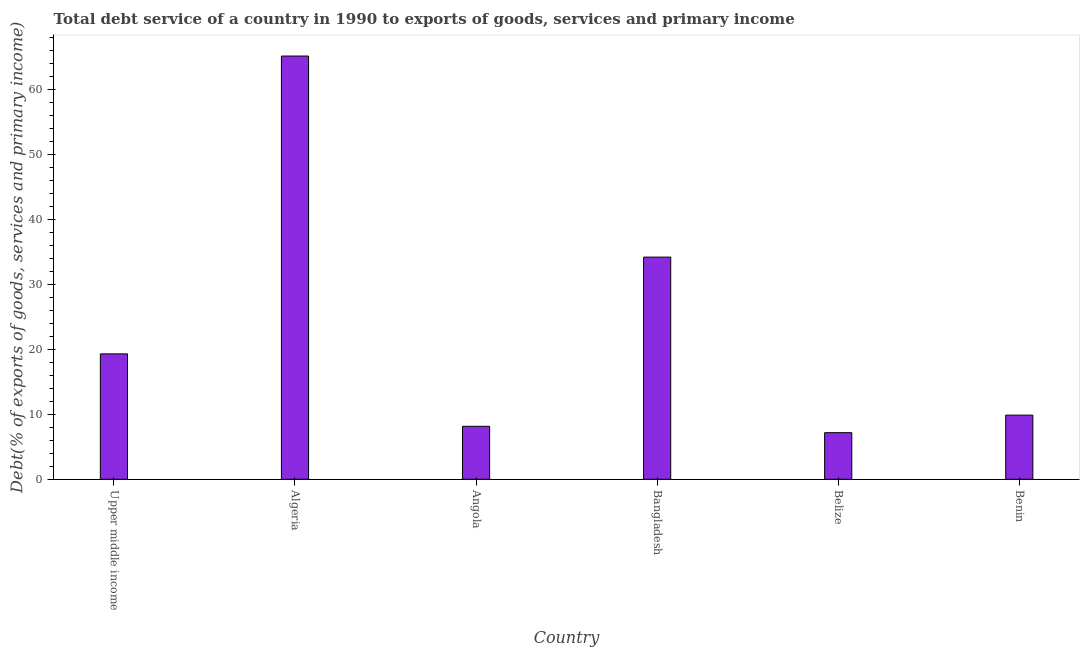What is the title of the graph?
Give a very brief answer. Total debt service of a country in 1990 to exports of goods, services and primary income. What is the label or title of the Y-axis?
Your response must be concise. Debt(% of exports of goods, services and primary income). What is the total debt service in Benin?
Ensure brevity in your answer.  9.86. Across all countries, what is the maximum total debt service?
Keep it short and to the point. 65.08. Across all countries, what is the minimum total debt service?
Ensure brevity in your answer.  7.17. In which country was the total debt service maximum?
Provide a succinct answer. Algeria. In which country was the total debt service minimum?
Make the answer very short. Belize. What is the sum of the total debt service?
Offer a terse response. 143.69. What is the difference between the total debt service in Algeria and Bangladesh?
Give a very brief answer. 30.92. What is the average total debt service per country?
Your response must be concise. 23.95. What is the median total debt service?
Your response must be concise. 14.57. What is the ratio of the total debt service in Angola to that in Bangladesh?
Keep it short and to the point. 0.24. Is the difference between the total debt service in Algeria and Belize greater than the difference between any two countries?
Your answer should be compact. Yes. What is the difference between the highest and the second highest total debt service?
Keep it short and to the point. 30.92. What is the difference between the highest and the lowest total debt service?
Provide a short and direct response. 57.91. How many bars are there?
Your response must be concise. 6. How many countries are there in the graph?
Your response must be concise. 6. What is the Debt(% of exports of goods, services and primary income) in Upper middle income?
Your response must be concise. 19.28. What is the Debt(% of exports of goods, services and primary income) in Algeria?
Provide a succinct answer. 65.08. What is the Debt(% of exports of goods, services and primary income) of Angola?
Offer a terse response. 8.14. What is the Debt(% of exports of goods, services and primary income) of Bangladesh?
Make the answer very short. 34.16. What is the Debt(% of exports of goods, services and primary income) in Belize?
Give a very brief answer. 7.17. What is the Debt(% of exports of goods, services and primary income) of Benin?
Make the answer very short. 9.86. What is the difference between the Debt(% of exports of goods, services and primary income) in Upper middle income and Algeria?
Provide a short and direct response. -45.8. What is the difference between the Debt(% of exports of goods, services and primary income) in Upper middle income and Angola?
Your response must be concise. 11.14. What is the difference between the Debt(% of exports of goods, services and primary income) in Upper middle income and Bangladesh?
Ensure brevity in your answer.  -14.88. What is the difference between the Debt(% of exports of goods, services and primary income) in Upper middle income and Belize?
Make the answer very short. 12.12. What is the difference between the Debt(% of exports of goods, services and primary income) in Upper middle income and Benin?
Offer a very short reply. 9.42. What is the difference between the Debt(% of exports of goods, services and primary income) in Algeria and Angola?
Give a very brief answer. 56.94. What is the difference between the Debt(% of exports of goods, services and primary income) in Algeria and Bangladesh?
Keep it short and to the point. 30.92. What is the difference between the Debt(% of exports of goods, services and primary income) in Algeria and Belize?
Provide a succinct answer. 57.91. What is the difference between the Debt(% of exports of goods, services and primary income) in Algeria and Benin?
Offer a terse response. 55.22. What is the difference between the Debt(% of exports of goods, services and primary income) in Angola and Bangladesh?
Offer a very short reply. -26.02. What is the difference between the Debt(% of exports of goods, services and primary income) in Angola and Belize?
Offer a terse response. 0.98. What is the difference between the Debt(% of exports of goods, services and primary income) in Angola and Benin?
Provide a short and direct response. -1.72. What is the difference between the Debt(% of exports of goods, services and primary income) in Bangladesh and Belize?
Make the answer very short. 26.99. What is the difference between the Debt(% of exports of goods, services and primary income) in Bangladesh and Benin?
Offer a very short reply. 24.3. What is the difference between the Debt(% of exports of goods, services and primary income) in Belize and Benin?
Provide a short and direct response. -2.7. What is the ratio of the Debt(% of exports of goods, services and primary income) in Upper middle income to that in Algeria?
Keep it short and to the point. 0.3. What is the ratio of the Debt(% of exports of goods, services and primary income) in Upper middle income to that in Angola?
Ensure brevity in your answer.  2.37. What is the ratio of the Debt(% of exports of goods, services and primary income) in Upper middle income to that in Bangladesh?
Provide a succinct answer. 0.56. What is the ratio of the Debt(% of exports of goods, services and primary income) in Upper middle income to that in Belize?
Your answer should be very brief. 2.69. What is the ratio of the Debt(% of exports of goods, services and primary income) in Upper middle income to that in Benin?
Your response must be concise. 1.96. What is the ratio of the Debt(% of exports of goods, services and primary income) in Algeria to that in Angola?
Give a very brief answer. 7.99. What is the ratio of the Debt(% of exports of goods, services and primary income) in Algeria to that in Bangladesh?
Offer a very short reply. 1.91. What is the ratio of the Debt(% of exports of goods, services and primary income) in Algeria to that in Belize?
Keep it short and to the point. 9.08. What is the ratio of the Debt(% of exports of goods, services and primary income) in Algeria to that in Benin?
Provide a succinct answer. 6.6. What is the ratio of the Debt(% of exports of goods, services and primary income) in Angola to that in Bangladesh?
Provide a succinct answer. 0.24. What is the ratio of the Debt(% of exports of goods, services and primary income) in Angola to that in Belize?
Give a very brief answer. 1.14. What is the ratio of the Debt(% of exports of goods, services and primary income) in Angola to that in Benin?
Provide a succinct answer. 0.82. What is the ratio of the Debt(% of exports of goods, services and primary income) in Bangladesh to that in Belize?
Offer a very short reply. 4.77. What is the ratio of the Debt(% of exports of goods, services and primary income) in Bangladesh to that in Benin?
Provide a succinct answer. 3.46. What is the ratio of the Debt(% of exports of goods, services and primary income) in Belize to that in Benin?
Give a very brief answer. 0.73. 